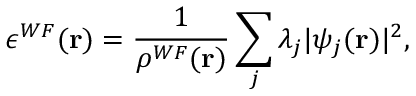Convert formula to latex. <formula><loc_0><loc_0><loc_500><loc_500>\epsilon ^ { W F } ( r ) = \frac { 1 } { \rho ^ { W F } ( r ) } \sum _ { j } \lambda _ { j } | \psi _ { j } ( r ) | ^ { 2 } ,</formula> 